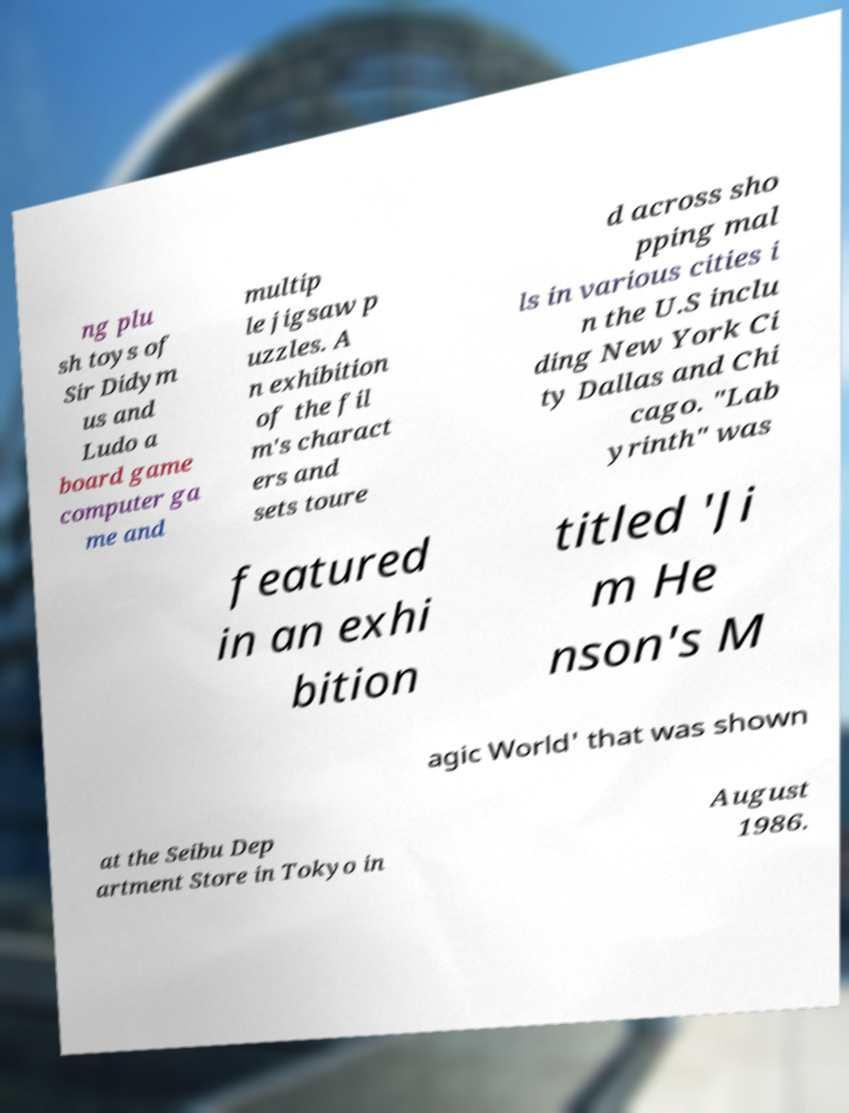Could you extract and type out the text from this image? ng plu sh toys of Sir Didym us and Ludo a board game computer ga me and multip le jigsaw p uzzles. A n exhibition of the fil m's charact ers and sets toure d across sho pping mal ls in various cities i n the U.S inclu ding New York Ci ty Dallas and Chi cago. "Lab yrinth" was featured in an exhi bition titled 'Ji m He nson's M agic World' that was shown at the Seibu Dep artment Store in Tokyo in August 1986. 